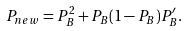Convert formula to latex. <formula><loc_0><loc_0><loc_500><loc_500>P _ { n e w } = P _ { B } ^ { 2 } + P _ { B } ( 1 - P _ { B } ) P ^ { \prime } _ { B } .</formula> 